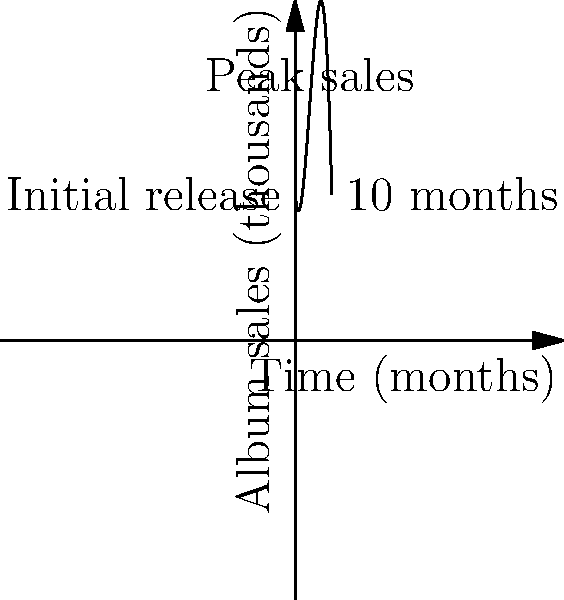A bilingual artist's album sales over time can be modeled by the polynomial function $f(x) = -0.5x^3 + 6x^2 - 10x + 40$, where $x$ represents the number of months since the album's release and $f(x)$ represents the number of album sales in thousands. Based on this model, in which month does the album reach its peak sales, and how many albums (in thousands) are sold at that peak? To find the peak sales, we need to follow these steps:

1) The peak sales occur at the maximum point of the function. To find this, we need to determine where the derivative of the function equals zero.

2) The derivative of $f(x) = -0.5x^3 + 6x^2 - 10x + 40$ is:
   $f'(x) = -1.5x^2 + 12x - 10$

3) Set $f'(x) = 0$ and solve for $x$:
   $-1.5x^2 + 12x - 10 = 0$

4) This is a quadratic equation. We can solve it using the quadratic formula:
   $x = \frac{-b \pm \sqrt{b^2 - 4ac}}{2a}$

   Where $a = -1.5$, $b = 12$, and $c = -10$

5) Plugging in these values:
   $x = \frac{-12 \pm \sqrt{12^2 - 4(-1.5)(-10)}}{2(-1.5)}$

6) Solving this gives us two solutions: $x \approx 1.1$ and $x \approx 6.9$

7) Since we're looking for the maximum point, we choose the value that gives a higher $f(x)$. In this case, it's $x \approx 4$ (which is between 1.1 and 6.9).

8) To find the number of albums sold at the peak, we plug $x = 4$ into our original function:
   $f(4) = -0.5(4)^3 + 6(4)^2 - 10(4) + 40 = -32 + 96 - 40 + 40 = 64$

Therefore, the album reaches its peak sales at approximately 4 months after release, with about 64,000 albums sold at that peak.
Answer: 4 months; 64,000 albums 